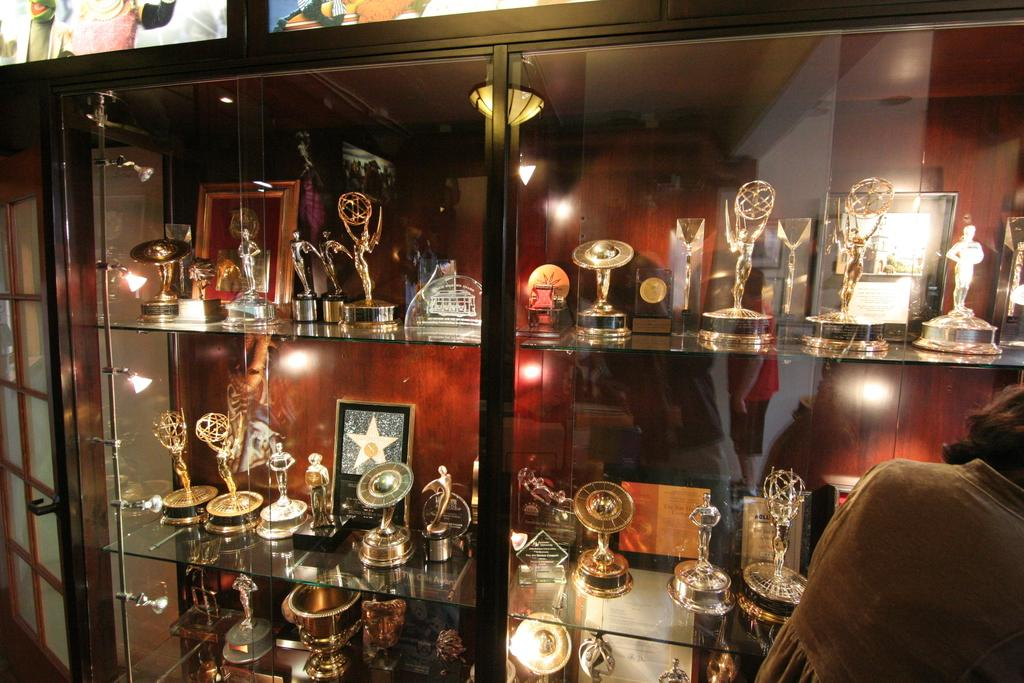What type of furniture is in the image? There is a glass cupboard in the image. What is unique about the glass cupboard? The glass cupboard has glass shelves. What items can be seen on the glass shelves? There are shields and mementos on the glass shelves. Where is the girl located in the image? The girl is on the right side bottom of the image. What is the name of the girl in the image? The provided facts do not mention the girl's name, so we cannot determine her name from the image. 